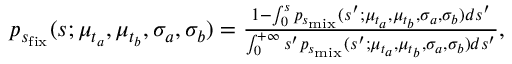Convert formula to latex. <formula><loc_0><loc_0><loc_500><loc_500>\begin{array} { r } { p _ { s _ { f i x } } ( s ; \mu _ { t _ { a } } , \mu _ { t _ { b } } , \sigma _ { a } , \sigma _ { b } ) = \frac { 1 - \int _ { 0 } ^ { s } p _ { s _ { m i x } } ( s ^ { \prime } ; \mu _ { t _ { a } } , \mu _ { t _ { b } } , \sigma _ { a } , \sigma _ { b } ) d s ^ { \prime } } { \int _ { 0 } ^ { + \infty } s ^ { \prime } p _ { s _ { m i x } } ( s ^ { \prime } ; \mu _ { t _ { a } } , \mu _ { t _ { b } } , \sigma _ { a } , \sigma _ { b } ) d s ^ { \prime } } , } \end{array}</formula> 